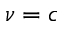<formula> <loc_0><loc_0><loc_500><loc_500>\nu = c</formula> 